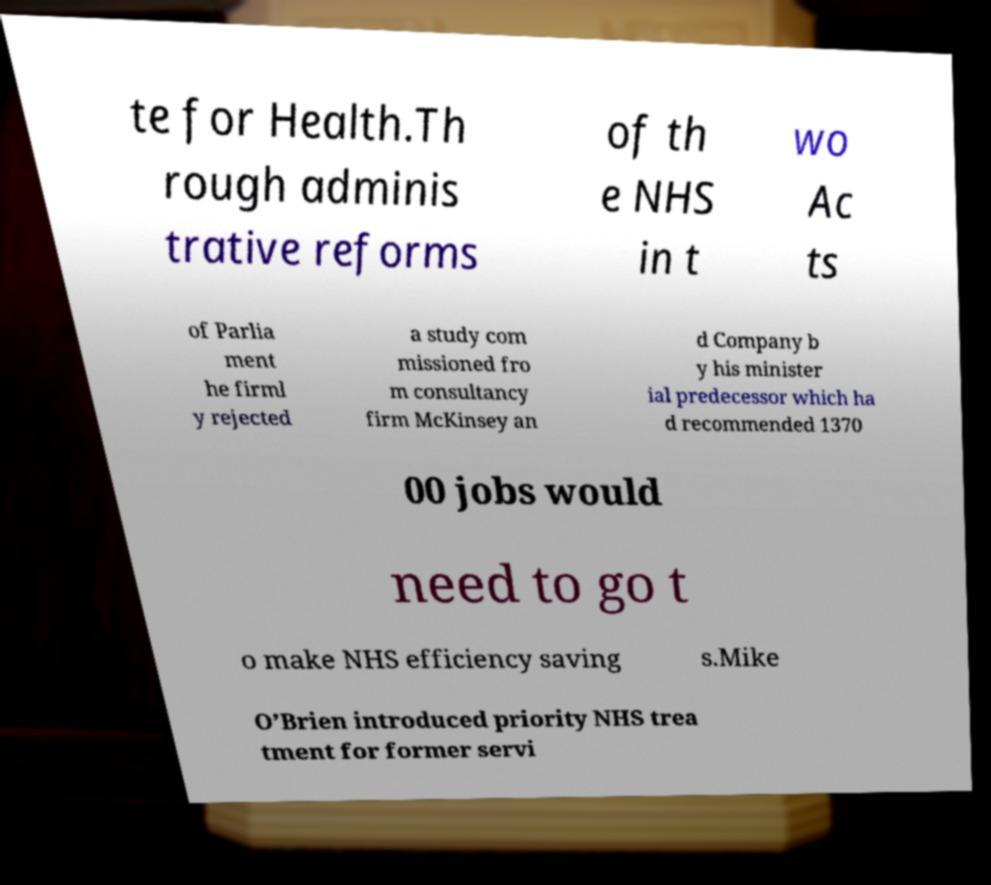What messages or text are displayed in this image? I need them in a readable, typed format. te for Health.Th rough adminis trative reforms of th e NHS in t wo Ac ts of Parlia ment he firml y rejected a study com missioned fro m consultancy firm McKinsey an d Company b y his minister ial predecessor which ha d recommended 1370 00 jobs would need to go t o make NHS efficiency saving s.Mike O’Brien introduced priority NHS trea tment for former servi 